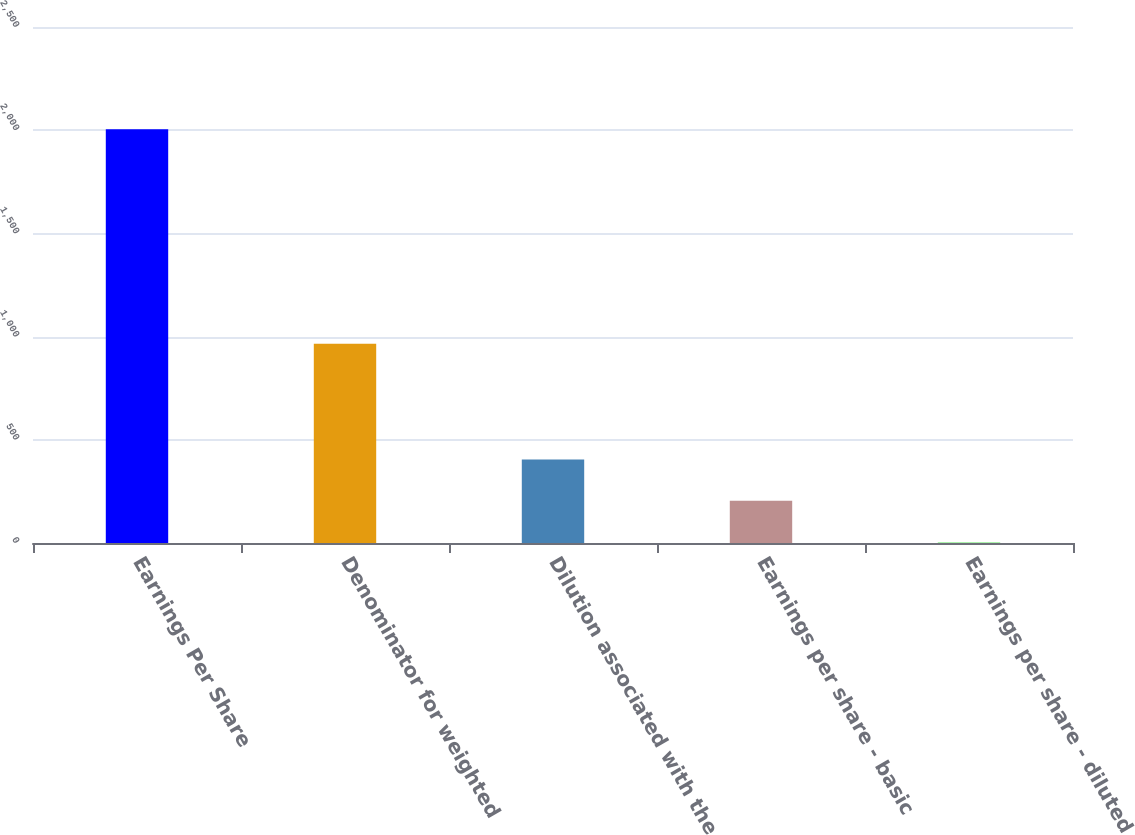Convert chart to OTSL. <chart><loc_0><loc_0><loc_500><loc_500><bar_chart><fcel>Earnings Per Share<fcel>Denominator for weighted<fcel>Dilution associated with the<fcel>Earnings per share - basic<fcel>Earnings per share - diluted<nl><fcel>2005<fcel>964.99<fcel>404.3<fcel>204.21<fcel>4.12<nl></chart> 